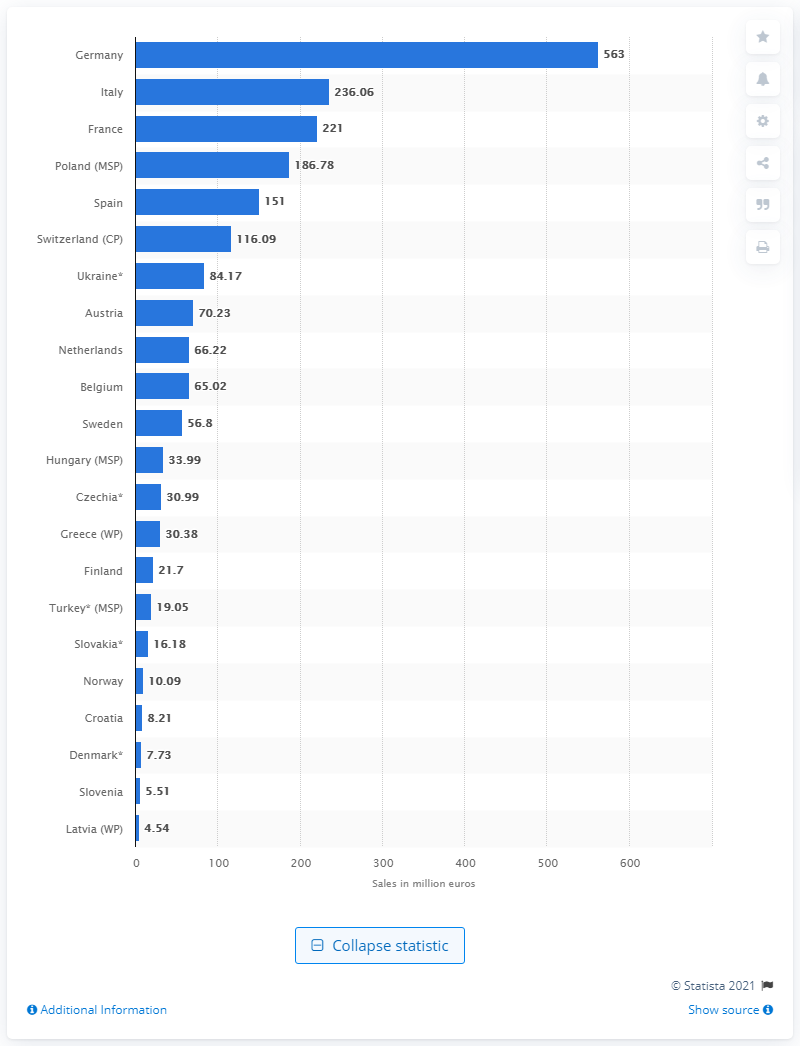Give some essential details in this illustration. Germany spent 563 million U.S. dollars on the sales of skin treatment products in 2017. Germany was the European country with the highest sales, reaching 563 million euros. 